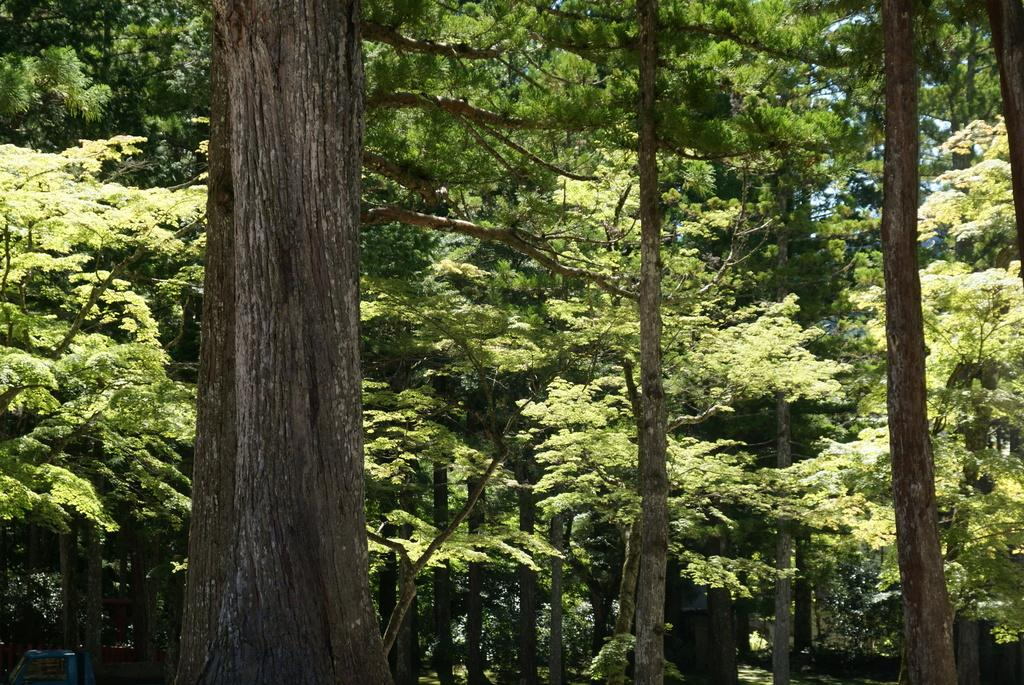What type of vegetation can be seen in the image? There are trees in the image. Can you describe the trees in the image? The provided facts do not give specific details about the trees, so we cannot describe them further. What might be the purpose of including trees in the image? The trees in the image could be included for aesthetic reasons, to provide a natural setting, or to convey a particular mood or atmosphere. What type of discussion is taking place among the snails in the image? There are no snails present in the image, so there cannot be a discussion among them. 